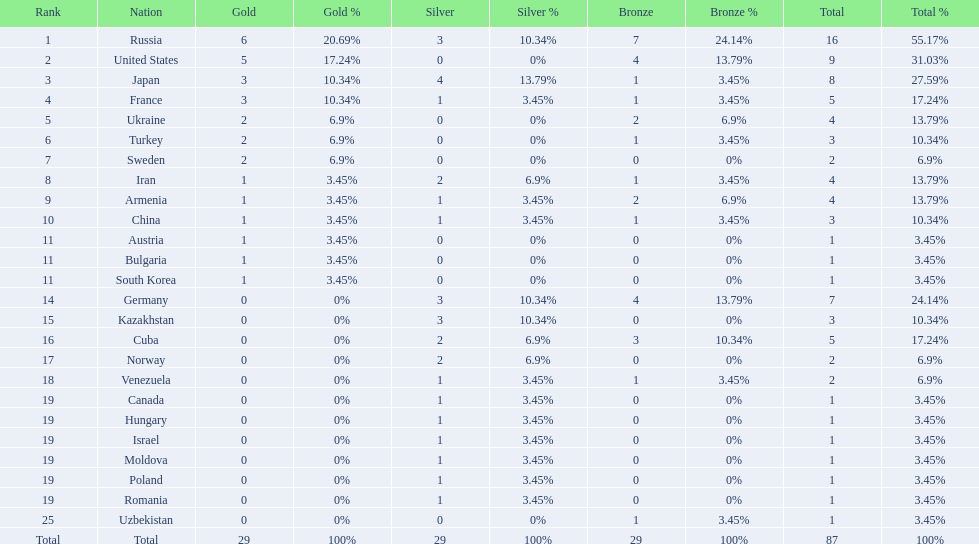Which nations participated in the championships? Russia, United States, Japan, France, Ukraine, Turkey, Sweden, Iran, Armenia, China, Austria, Bulgaria, South Korea, Germany, Kazakhstan, Cuba, Norway, Venezuela, Canada, Hungary, Israel, Moldova, Poland, Romania, Uzbekistan. How many bronze medals did they receive? 7, 4, 1, 1, 2, 1, 0, 1, 2, 1, 0, 0, 0, 4, 0, 3, 0, 1, 0, 0, 0, 0, 0, 0, 1, 29. How many in total? 16, 9, 8, 5, 4, 3, 2, 4, 4, 3, 1, 1, 1, 7, 3, 5, 2, 2, 1, 1, 1, 1, 1, 1, 1. Can you give me this table in json format? {'header': ['Rank', 'Nation', 'Gold', 'Gold %', 'Silver', 'Silver %', 'Bronze', 'Bronze %', 'Total', 'Total %'], 'rows': [['1', 'Russia', '6', '20.69%', '3', '10.34%', '7', '24.14%', '16', '55.17%'], ['2', 'United States', '5', '17.24%', '0', '0%', '4', '13.79%', '9', '31.03%'], ['3', 'Japan', '3', '10.34%', '4', '13.79%', '1', '3.45%', '8', '27.59%'], ['4', 'France', '3', '10.34%', '1', '3.45%', '1', '3.45%', '5', '17.24%'], ['5', 'Ukraine', '2', '6.9%', '0', '0%', '2', '6.9%', '4', '13.79%'], ['6', 'Turkey', '2', '6.9%', '0', '0%', '1', '3.45%', '3', '10.34%'], ['7', 'Sweden', '2', '6.9%', '0', '0%', '0', '0%', '2', '6.9%'], ['8', 'Iran', '1', '3.45%', '2', '6.9%', '1', '3.45%', '4', '13.79%'], ['9', 'Armenia', '1', '3.45%', '1', '3.45%', '2', '6.9%', '4', '13.79%'], ['10', 'China', '1', '3.45%', '1', '3.45%', '1', '3.45%', '3', '10.34%'], ['11', 'Austria', '1', '3.45%', '0', '0%', '0', '0%', '1', '3.45%'], ['11', 'Bulgaria', '1', '3.45%', '0', '0%', '0', '0%', '1', '3.45%'], ['11', 'South Korea', '1', '3.45%', '0', '0%', '0', '0%', '1', '3.45%'], ['14', 'Germany', '0', '0%', '3', '10.34%', '4', '13.79%', '7', '24.14%'], ['15', 'Kazakhstan', '0', '0%', '3', '10.34%', '0', '0%', '3', '10.34%'], ['16', 'Cuba', '0', '0%', '2', '6.9%', '3', '10.34%', '5', '17.24%'], ['17', 'Norway', '0', '0%', '2', '6.9%', '0', '0%', '2', '6.9%'], ['18', 'Venezuela', '0', '0%', '1', '3.45%', '1', '3.45%', '2', '6.9%'], ['19', 'Canada', '0', '0%', '1', '3.45%', '0', '0%', '1', '3.45%'], ['19', 'Hungary', '0', '0%', '1', '3.45%', '0', '0%', '1', '3.45%'], ['19', 'Israel', '0', '0%', '1', '3.45%', '0', '0%', '1', '3.45%'], ['19', 'Moldova', '0', '0%', '1', '3.45%', '0', '0%', '1', '3.45%'], ['19', 'Poland', '0', '0%', '1', '3.45%', '0', '0%', '1', '3.45%'], ['19', 'Romania', '0', '0%', '1', '3.45%', '0', '0%', '1', '3.45%'], ['25', 'Uzbekistan', '0', '0%', '0', '0%', '1', '3.45%', '1', '3.45%'], ['Total', 'Total', '29', '100%', '29', '100%', '29', '100%', '87', '100%']]} And which team won only one medal -- the bronze? Uzbekistan. 